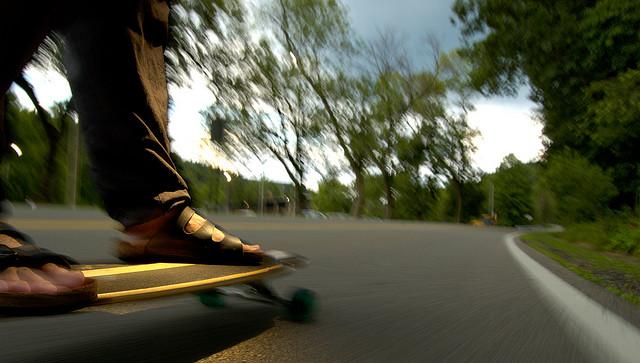What is the man on?
Short answer required. Skateboard. Are both lines on the road white?
Concise answer only. No. Is the person moving?
Keep it brief. Yes. 